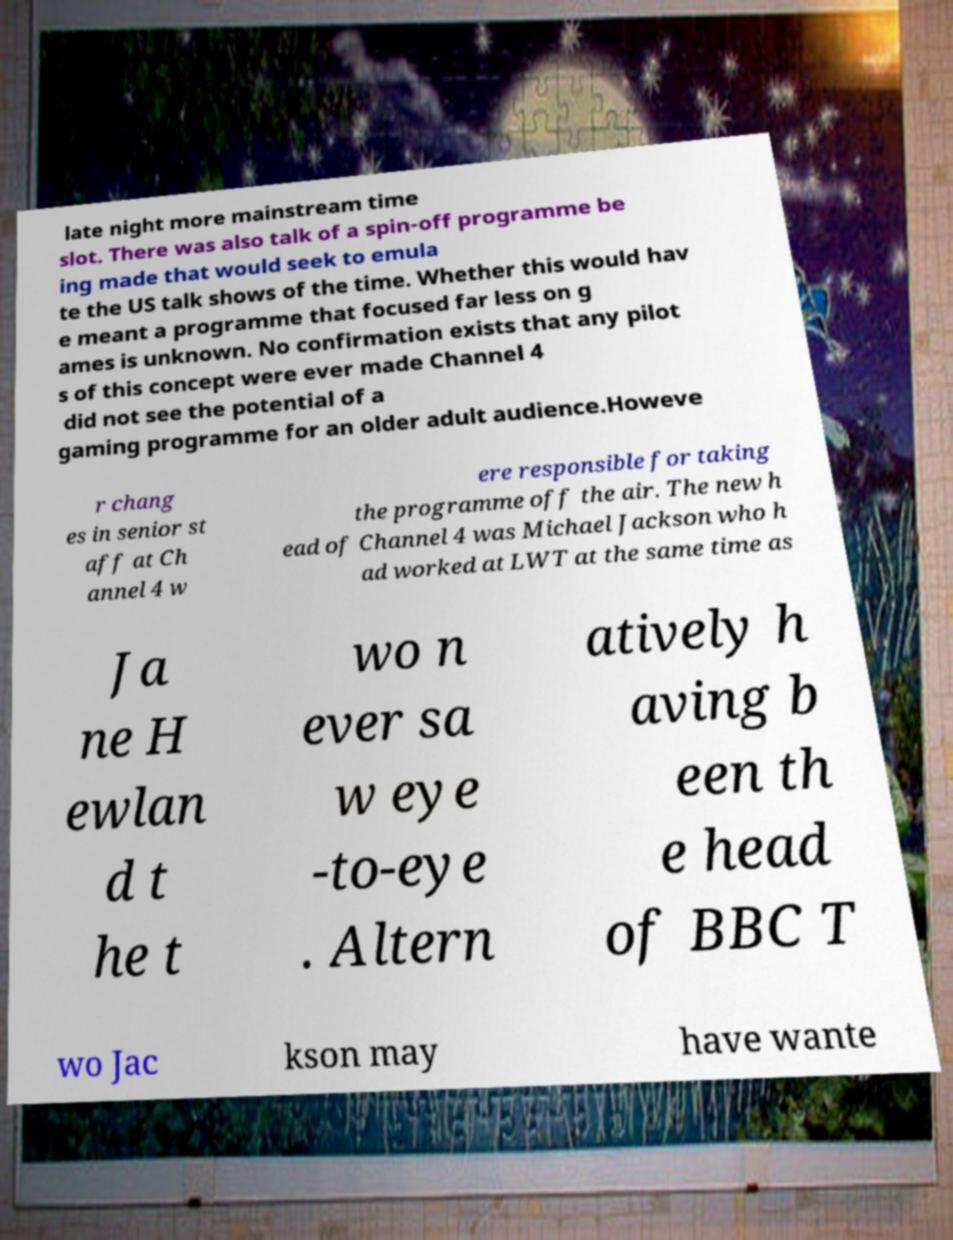Please identify and transcribe the text found in this image. late night more mainstream time slot. There was also talk of a spin-off programme be ing made that would seek to emula te the US talk shows of the time. Whether this would hav e meant a programme that focused far less on g ames is unknown. No confirmation exists that any pilot s of this concept were ever made Channel 4 did not see the potential of a gaming programme for an older adult audience.Howeve r chang es in senior st aff at Ch annel 4 w ere responsible for taking the programme off the air. The new h ead of Channel 4 was Michael Jackson who h ad worked at LWT at the same time as Ja ne H ewlan d t he t wo n ever sa w eye -to-eye . Altern atively h aving b een th e head of BBC T wo Jac kson may have wante 